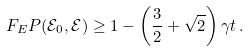Convert formula to latex. <formula><loc_0><loc_0><loc_500><loc_500>F _ { E } P ( \mathcal { E } _ { 0 } , \mathcal { E } ) \geq 1 - \left ( \frac { 3 } { 2 } + \sqrt { 2 } \right ) \gamma t \, .</formula> 